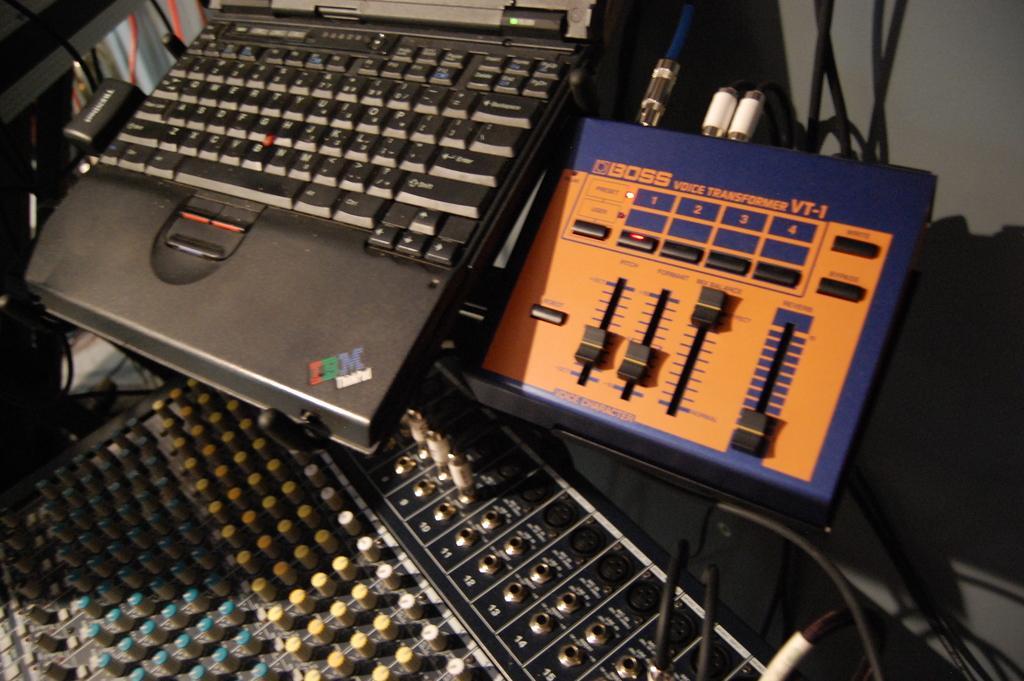Describe this image in one or two sentences. In the picture I can see a laptop, wires and other electronic machines. The laptop is black in color and there is a logo on it. 